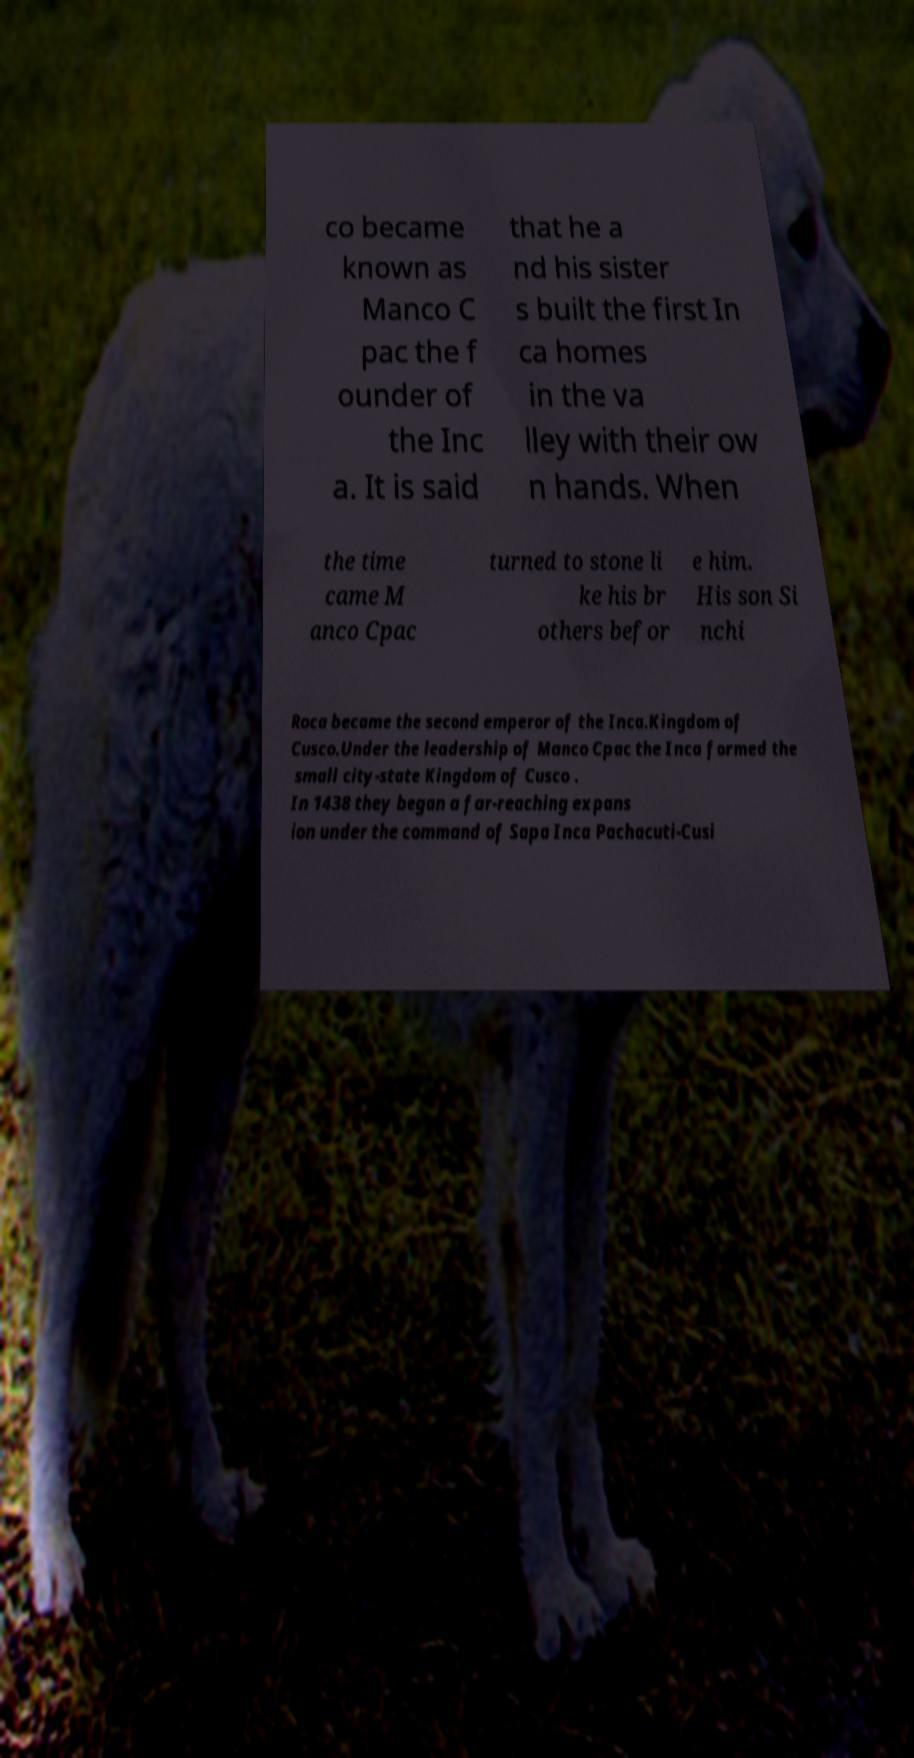I need the written content from this picture converted into text. Can you do that? co became known as Manco C pac the f ounder of the Inc a. It is said that he a nd his sister s built the first In ca homes in the va lley with their ow n hands. When the time came M anco Cpac turned to stone li ke his br others befor e him. His son Si nchi Roca became the second emperor of the Inca.Kingdom of Cusco.Under the leadership of Manco Cpac the Inca formed the small city-state Kingdom of Cusco . In 1438 they began a far-reaching expans ion under the command of Sapa Inca Pachacuti-Cusi 